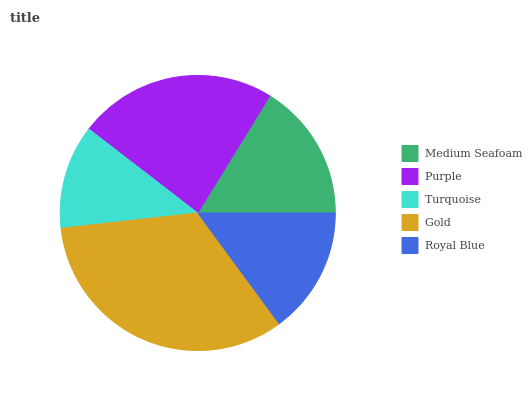Is Turquoise the minimum?
Answer yes or no. Yes. Is Gold the maximum?
Answer yes or no. Yes. Is Purple the minimum?
Answer yes or no. No. Is Purple the maximum?
Answer yes or no. No. Is Purple greater than Medium Seafoam?
Answer yes or no. Yes. Is Medium Seafoam less than Purple?
Answer yes or no. Yes. Is Medium Seafoam greater than Purple?
Answer yes or no. No. Is Purple less than Medium Seafoam?
Answer yes or no. No. Is Medium Seafoam the high median?
Answer yes or no. Yes. Is Medium Seafoam the low median?
Answer yes or no. Yes. Is Turquoise the high median?
Answer yes or no. No. Is Royal Blue the low median?
Answer yes or no. No. 